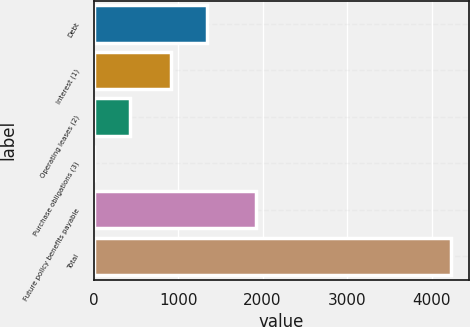Convert chart. <chart><loc_0><loc_0><loc_500><loc_500><bar_chart><fcel>Debt<fcel>Interest (1)<fcel>Operating leases (2)<fcel>Purchase obligations (3)<fcel>Future policy benefits payable<fcel>Total<nl><fcel>1340.31<fcel>917<fcel>424.21<fcel>0.9<fcel>1924<fcel>4234<nl></chart> 